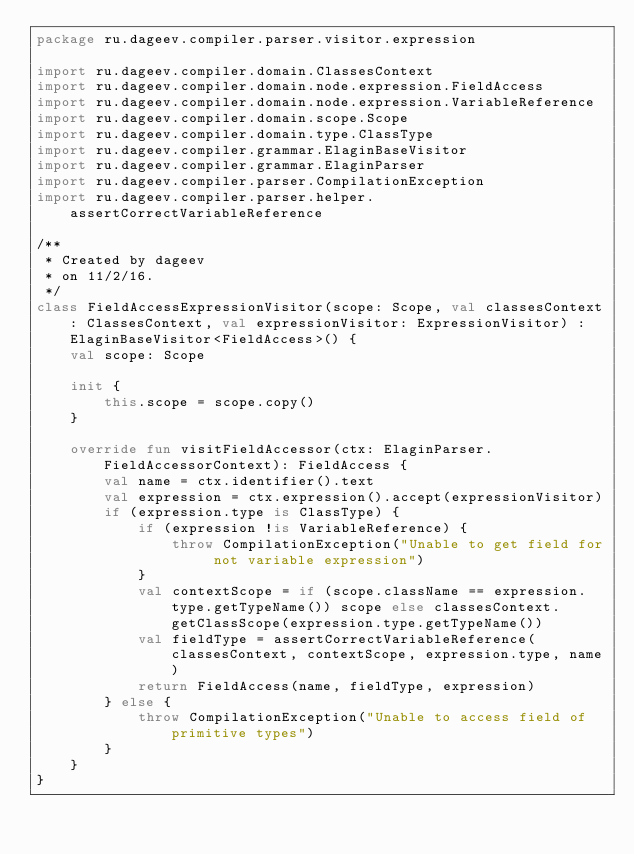<code> <loc_0><loc_0><loc_500><loc_500><_Kotlin_>package ru.dageev.compiler.parser.visitor.expression

import ru.dageev.compiler.domain.ClassesContext
import ru.dageev.compiler.domain.node.expression.FieldAccess
import ru.dageev.compiler.domain.node.expression.VariableReference
import ru.dageev.compiler.domain.scope.Scope
import ru.dageev.compiler.domain.type.ClassType
import ru.dageev.compiler.grammar.ElaginBaseVisitor
import ru.dageev.compiler.grammar.ElaginParser
import ru.dageev.compiler.parser.CompilationException
import ru.dageev.compiler.parser.helper.assertCorrectVariableReference

/**
 * Created by dageev
 * on 11/2/16.
 */
class FieldAccessExpressionVisitor(scope: Scope, val classesContext: ClassesContext, val expressionVisitor: ExpressionVisitor) : ElaginBaseVisitor<FieldAccess>() {
    val scope: Scope

    init {
        this.scope = scope.copy()
    }

    override fun visitFieldAccessor(ctx: ElaginParser.FieldAccessorContext): FieldAccess {
        val name = ctx.identifier().text
        val expression = ctx.expression().accept(expressionVisitor)
        if (expression.type is ClassType) {
            if (expression !is VariableReference) {
                throw CompilationException("Unable to get field for not variable expression")
            }
            val contextScope = if (scope.className == expression.type.getTypeName()) scope else classesContext.getClassScope(expression.type.getTypeName())
            val fieldType = assertCorrectVariableReference(classesContext, contextScope, expression.type, name)
            return FieldAccess(name, fieldType, expression)
        } else {
            throw CompilationException("Unable to access field of primitive types")
        }
    }
}</code> 